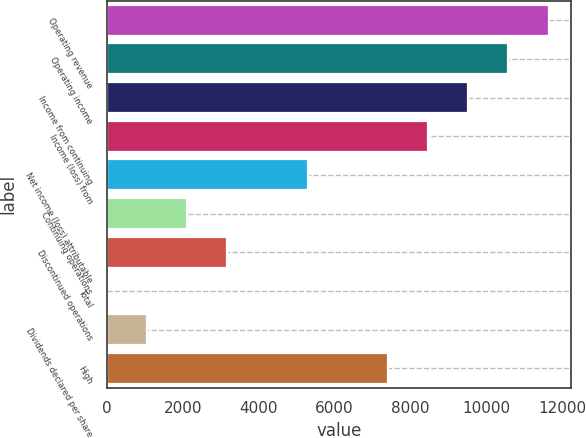Convert chart. <chart><loc_0><loc_0><loc_500><loc_500><bar_chart><fcel>Operating revenue<fcel>Operating income<fcel>Income from continuing<fcel>Income (loss) from<fcel>Net income (loss) attributable<fcel>Continuing operations<fcel>Discontinued operations<fcel>Total<fcel>Dividends declared per share<fcel>High<nl><fcel>11646.8<fcel>10588<fcel>9529.22<fcel>8470.43<fcel>5294.06<fcel>2117.69<fcel>3176.48<fcel>0.11<fcel>1058.9<fcel>7411.64<nl></chart> 